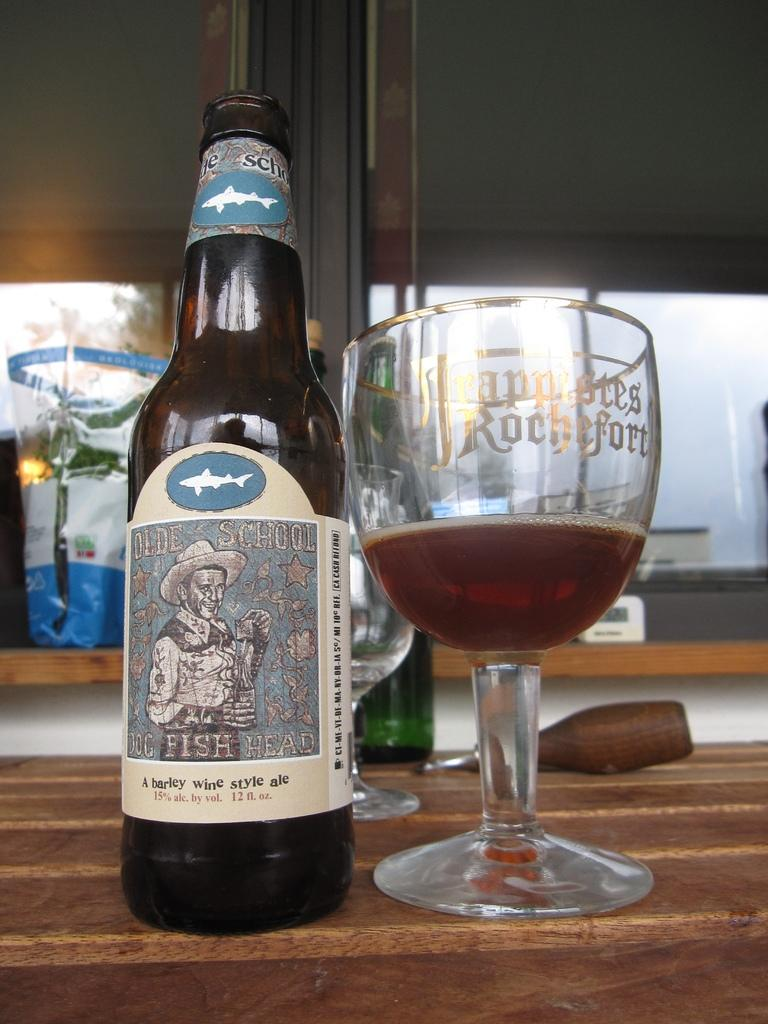What objects are on the table in the image? There is a bottle and a glass on the table in the image. What is depicted on the bottle? The bottle has a picture of a man on it. What is the man in the picture wearing? The man in the picture is wearing a cap. What type of trail can be seen leading to the edge of the image? There is no trail or edge present in the image; it features a bottle and a glass on a table. 